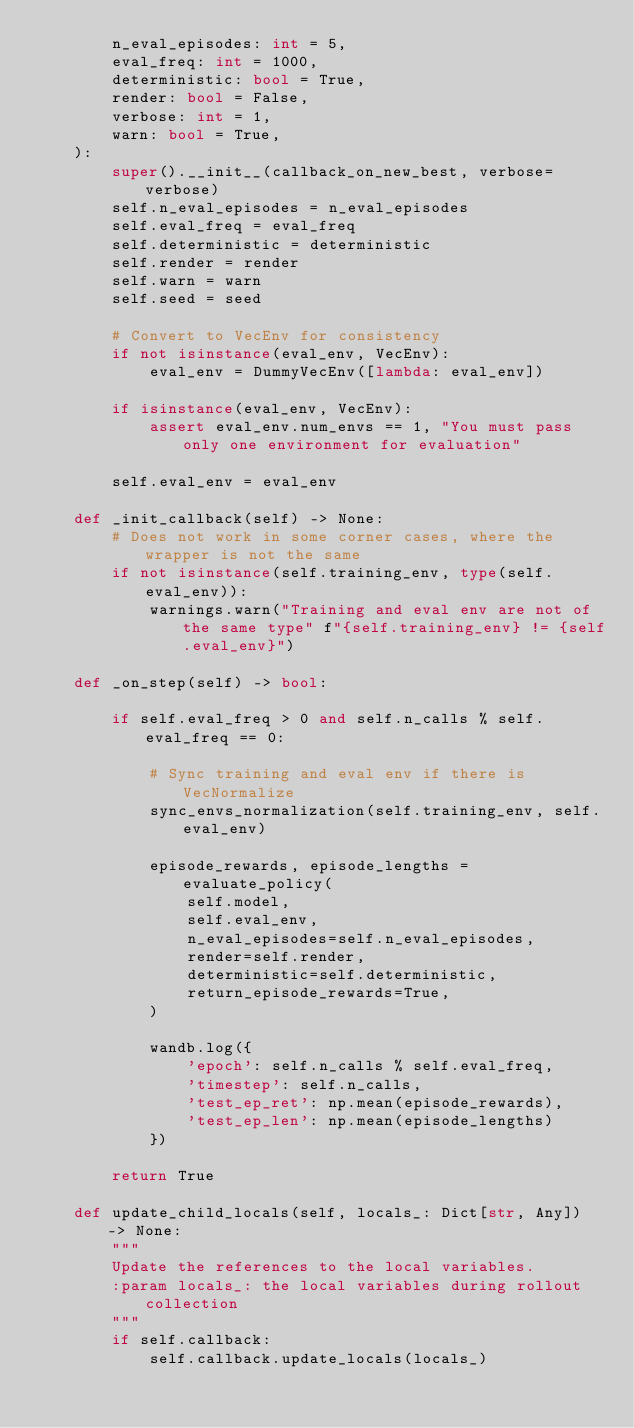<code> <loc_0><loc_0><loc_500><loc_500><_Python_>        n_eval_episodes: int = 5,
        eval_freq: int = 1000,
        deterministic: bool = True,
        render: bool = False,
        verbose: int = 1,
        warn: bool = True,
    ):
        super().__init__(callback_on_new_best, verbose=verbose)
        self.n_eval_episodes = n_eval_episodes
        self.eval_freq = eval_freq
        self.deterministic = deterministic
        self.render = render
        self.warn = warn
        self.seed = seed

        # Convert to VecEnv for consistency
        if not isinstance(eval_env, VecEnv):
            eval_env = DummyVecEnv([lambda: eval_env])

        if isinstance(eval_env, VecEnv):
            assert eval_env.num_envs == 1, "You must pass only one environment for evaluation"

        self.eval_env = eval_env

    def _init_callback(self) -> None:
        # Does not work in some corner cases, where the wrapper is not the same
        if not isinstance(self.training_env, type(self.eval_env)):
            warnings.warn("Training and eval env are not of the same type" f"{self.training_env} != {self.eval_env}")

    def _on_step(self) -> bool:

        if self.eval_freq > 0 and self.n_calls % self.eval_freq == 0:

            # Sync training and eval env if there is VecNormalize
            sync_envs_normalization(self.training_env, self.eval_env)

            episode_rewards, episode_lengths = evaluate_policy(
                self.model,
                self.eval_env,
                n_eval_episodes=self.n_eval_episodes,
                render=self.render,
                deterministic=self.deterministic,
                return_episode_rewards=True,
            )

            wandb.log({
                'epoch': self.n_calls % self.eval_freq,
                'timestep': self.n_calls,
                'test_ep_ret': np.mean(episode_rewards),
                'test_ep_len': np.mean(episode_lengths)
            })

        return True

    def update_child_locals(self, locals_: Dict[str, Any]) -> None:
        """
        Update the references to the local variables.
        :param locals_: the local variables during rollout collection
        """
        if self.callback:
            self.callback.update_locals(locals_)</code> 